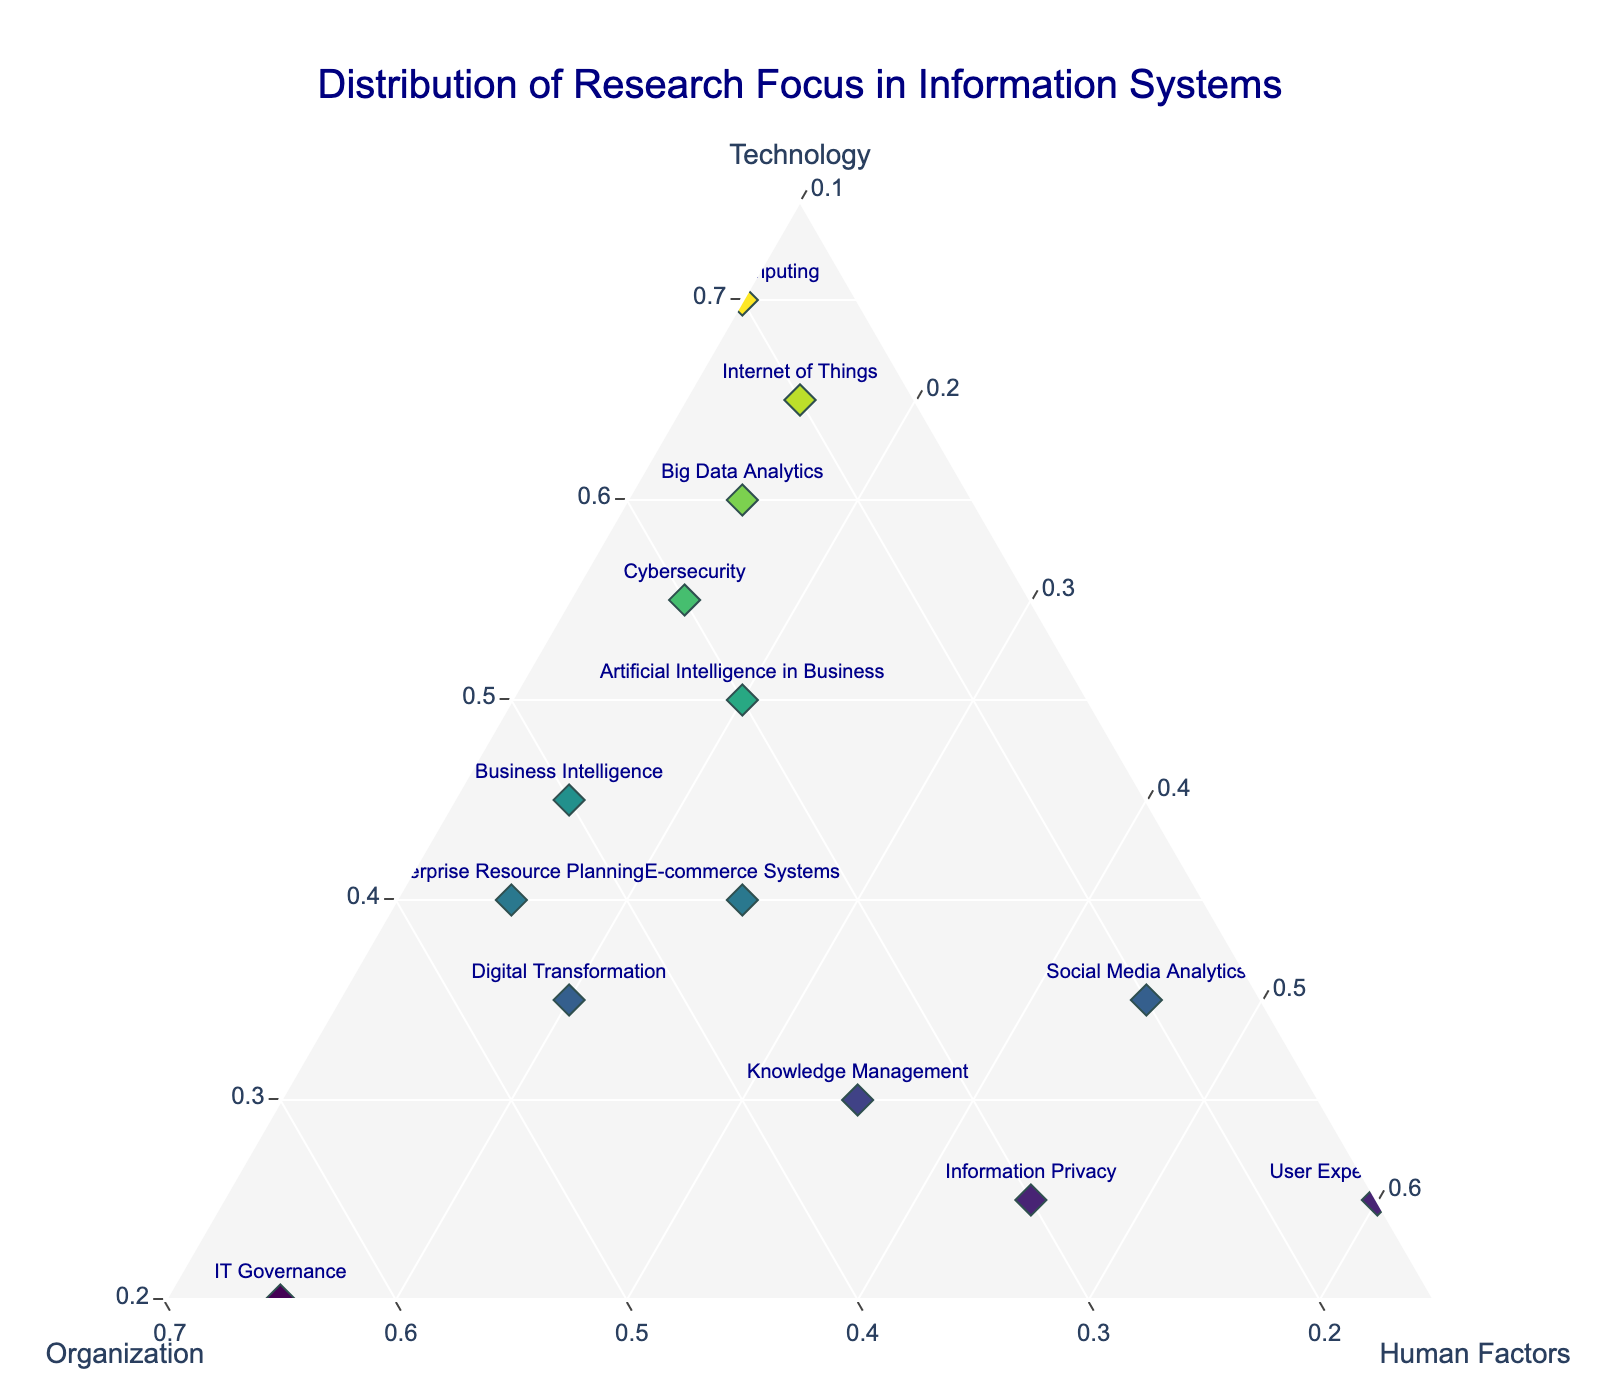What is the title of the figure? The title of the figure is typically displayed at the top to provide an overview of what the figure represents. In this case, the title is aligned to the center.
Answer: Distribution of Research Focus in Information Systems How many research areas focus predominantly on Technology? To determine this, count the data points whose 'Technology' value is higher than both 'Organization' and 'Human Factors'.
Answer: 6 Which research area has the highest focus on Human Factors? Identify the data point closest to the 'Human Factors' axis, which has the greatest proportion of Human Factors.
Answer: User Experience Design Compare the focus on Organization between IT Governance and Knowledge Management. Which one has a higher value? Examine the exact positions for both data points along the Organization axis. IT Governance has a value of 0.65, while Knowledge Management has 0.35.
Answer: IT Governance Are there any research areas where Human Factors are equal to or greater than 0.45? If so, which ones? Check the values for Human Factors and identify any that meet or exceed 0.45.
Answer: Social Media Analytics, Information Privacy What is the average focus on Technology across all research areas? Sum the 'Technology' values for all research areas and divide by the total number of data points (14). \( \frac{0.60+0.70+0.55+0.40+0.30+0.45+0.35+0.65+0.50+0.35+0.40+0.25+0.20+0.25}{14} = 0.43 \)
Answer: 0.43 Which research area has the smallest focus on Organization? Identify the data point furthest from the 'Organization' axis, with the smallest 'Organization' value.
Answer: User Experience Design What is the combined focus on Human Factors for Cloud Computing and Cybersecurity? Sum the 'Human Factors' values for Cloud Computing and Cybersecurity. \( 0.10 + 0.15 = 0.25 \)
Answer: 0.25 Compare the Technology focus between Cybersecurity and Artificial Intelligence in Business, and identify which has a higher value. Examine the values for both data points along the Technology axis. Cybersecurity has 0.55 and Artificial Intelligence in Business has 0.50.
Answer: Cybersecurity What is the median value of Organization focus across all research areas? Sort the 'Organization' values and find the middle value. The sorted values are \( 0.15, 0.15, 0.20, 0.20, 0.30, 0.30, 0.35, 0.35, 0.35, 0.40, 0.45, 0.45, 0.45, 0.65 \). The median is the average of the 7th and 8th values. (0.35 + 0.35) / 2
Answer: 0.35 